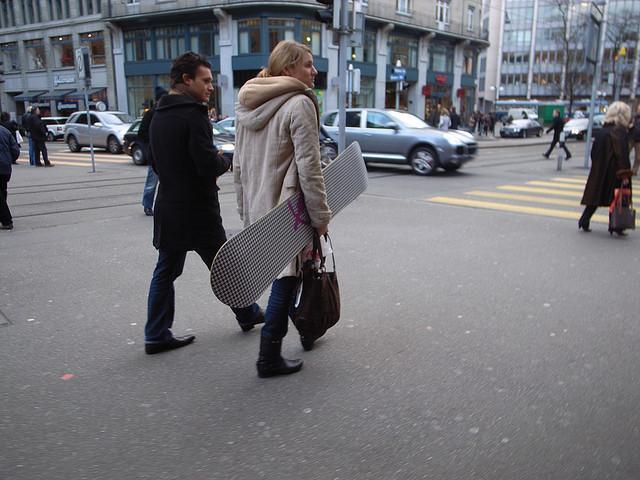How many people are in the photo?
Give a very brief answer. 3. How many cars can be seen?
Give a very brief answer. 2. How many zebras are shown?
Give a very brief answer. 0. 